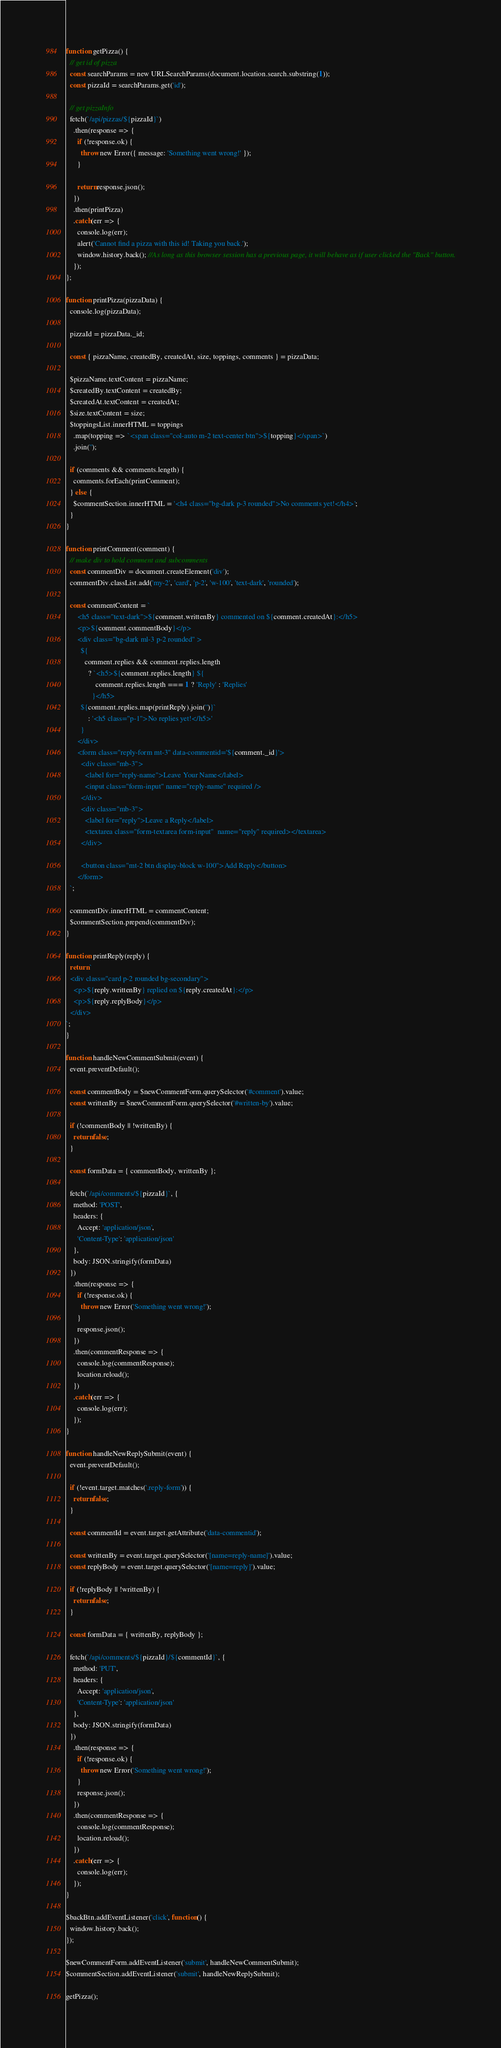Convert code to text. <code><loc_0><loc_0><loc_500><loc_500><_JavaScript_>function getPizza() {
  // get id of pizza
  const searchParams = new URLSearchParams(document.location.search.substring(1));
  const pizzaId = searchParams.get('id');

  // get pizzaInfo
  fetch(`/api/pizzas/${pizzaId}`)
    .then(response => {
      if (!response.ok) {
        throw new Error({ message: 'Something went wrong!' });
      }

      return response.json();
    })
    .then(printPizza)
    .catch(err => {
      console.log(err);
      alert('Cannot find a pizza with this id! Taking you back.');
      window.history.back(); //As long as this browser session has a previous page, it will behave as if user clicked the "Back" button.
    });
};

function printPizza(pizzaData) {
  console.log(pizzaData);

  pizzaId = pizzaData._id;

  const { pizzaName, createdBy, createdAt, size, toppings, comments } = pizzaData;

  $pizzaName.textContent = pizzaName;
  $createdBy.textContent = createdBy;
  $createdAt.textContent = createdAt;
  $size.textContent = size;
  $toppingsList.innerHTML = toppings
    .map(topping => `<span class="col-auto m-2 text-center btn">${topping}</span>`)
    .join('');

  if (comments && comments.length) {
    comments.forEach(printComment);
  } else {
    $commentSection.innerHTML = '<h4 class="bg-dark p-3 rounded">No comments yet!</h4>';
  }
}

function printComment(comment) {
  // make div to hold comment and subcomments
  const commentDiv = document.createElement('div');
  commentDiv.classList.add('my-2', 'card', 'p-2', 'w-100', 'text-dark', 'rounded');

  const commentContent = `
      <h5 class="text-dark">${comment.writtenBy} commented on ${comment.createdAt}:</h5>
      <p>${comment.commentBody}</p>
      <div class="bg-dark ml-3 p-2 rounded" >
        ${
          comment.replies && comment.replies.length
            ? `<h5>${comment.replies.length} ${
                comment.replies.length === 1 ? 'Reply' : 'Replies'
              }</h5>
        ${comment.replies.map(printReply).join('')}`
            : '<h5 class="p-1">No replies yet!</h5>'
        }
      </div>
      <form class="reply-form mt-3" data-commentid='${comment._id}'>
        <div class="mb-3">
          <label for="reply-name">Leave Your Name</label>
          <input class="form-input" name="reply-name" required />
        </div>
        <div class="mb-3">
          <label for="reply">Leave a Reply</label>
          <textarea class="form-textarea form-input"  name="reply" required></textarea>
        </div>

        <button class="mt-2 btn display-block w-100">Add Reply</button>
      </form>
  `;

  commentDiv.innerHTML = commentContent;
  $commentSection.prepend(commentDiv);
}

function printReply(reply) {
  return `
  <div class="card p-2 rounded bg-secondary">
    <p>${reply.writtenBy} replied on ${reply.createdAt}:</p>
    <p>${reply.replyBody}</p>
  </div>
`;
}

function handleNewCommentSubmit(event) {
  event.preventDefault();

  const commentBody = $newCommentForm.querySelector('#comment').value;
  const writtenBy = $newCommentForm.querySelector('#written-by').value;

  if (!commentBody || !writtenBy) {
    return false;
  }

  const formData = { commentBody, writtenBy };

  fetch(`/api/comments/${pizzaId}`, {
    method: 'POST',
    headers: {
      Accept: 'application/json',
      'Content-Type': 'application/json'
    },
    body: JSON.stringify(formData)
  })
    .then(response => {
      if (!response.ok) {
        throw new Error('Something went wrong!');
      }
      response.json();
    })
    .then(commentResponse => {
      console.log(commentResponse);
      location.reload();
    })
    .catch(err => {
      console.log(err);
    });
}

function handleNewReplySubmit(event) {
  event.preventDefault();

  if (!event.target.matches('.reply-form')) {
    return false;
  }

  const commentId = event.target.getAttribute('data-commentid');

  const writtenBy = event.target.querySelector('[name=reply-name]').value;
  const replyBody = event.target.querySelector('[name=reply]').value;

  if (!replyBody || !writtenBy) {
    return false;
  }

  const formData = { writtenBy, replyBody };

  fetch(`/api/comments/${pizzaId}/${commentId}`, {
    method: 'PUT',
    headers: {
      Accept: 'application/json',
      'Content-Type': 'application/json'
    },
    body: JSON.stringify(formData)
  })
    .then(response => {
      if (!response.ok) {
        throw new Error('Something went wrong!');
      }
      response.json();
    })
    .then(commentResponse => {
      console.log(commentResponse);
      location.reload();
    })
    .catch(err => {
      console.log(err);
    });
}

$backBtn.addEventListener('click', function() {
  window.history.back();
});

$newCommentForm.addEventListener('submit', handleNewCommentSubmit);
$commentSection.addEventListener('submit', handleNewReplySubmit);

getPizza();</code> 